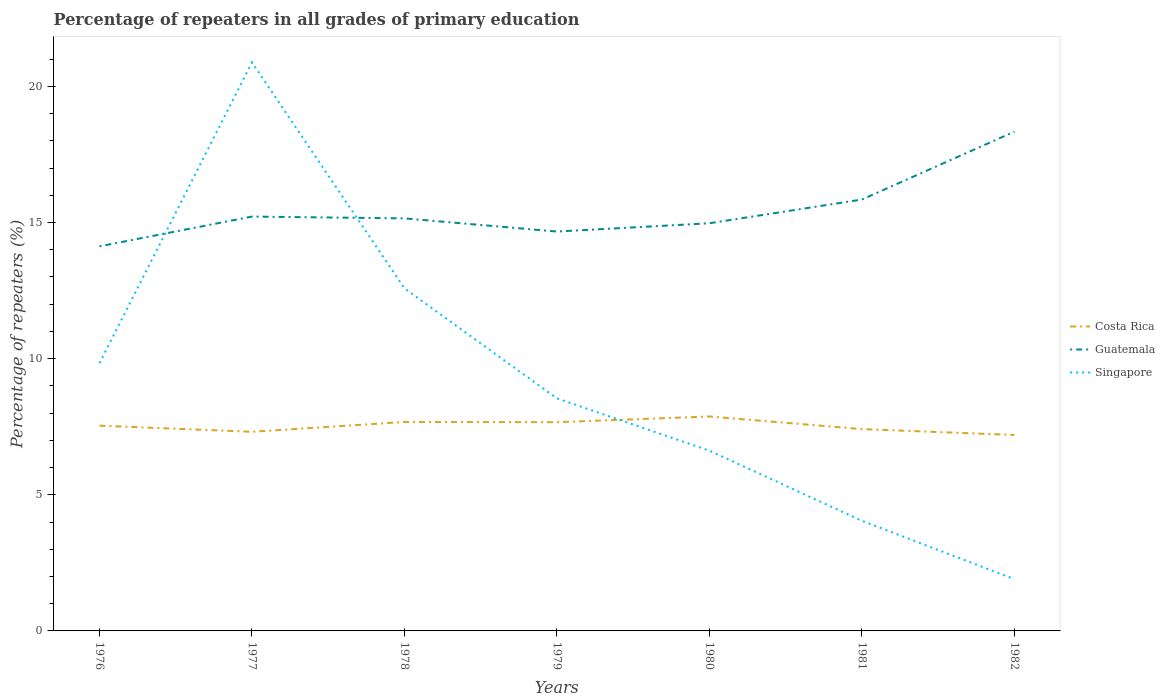Across all years, what is the maximum percentage of repeaters in Costa Rica?
Provide a succinct answer. 7.2. In which year was the percentage of repeaters in Singapore maximum?
Make the answer very short. 1982. What is the total percentage of repeaters in Costa Rica in the graph?
Make the answer very short. 0.01. What is the difference between the highest and the second highest percentage of repeaters in Costa Rica?
Make the answer very short. 0.68. Is the percentage of repeaters in Costa Rica strictly greater than the percentage of repeaters in Singapore over the years?
Your response must be concise. No. What is the difference between two consecutive major ticks on the Y-axis?
Offer a terse response. 5. Where does the legend appear in the graph?
Give a very brief answer. Center right. What is the title of the graph?
Make the answer very short. Percentage of repeaters in all grades of primary education. Does "Oman" appear as one of the legend labels in the graph?
Give a very brief answer. No. What is the label or title of the X-axis?
Your answer should be very brief. Years. What is the label or title of the Y-axis?
Provide a short and direct response. Percentage of repeaters (%). What is the Percentage of repeaters (%) of Costa Rica in 1976?
Give a very brief answer. 7.54. What is the Percentage of repeaters (%) in Guatemala in 1976?
Your response must be concise. 14.12. What is the Percentage of repeaters (%) in Singapore in 1976?
Provide a short and direct response. 9.83. What is the Percentage of repeaters (%) in Costa Rica in 1977?
Ensure brevity in your answer.  7.31. What is the Percentage of repeaters (%) in Guatemala in 1977?
Provide a succinct answer. 15.22. What is the Percentage of repeaters (%) of Singapore in 1977?
Ensure brevity in your answer.  20.88. What is the Percentage of repeaters (%) in Costa Rica in 1978?
Give a very brief answer. 7.67. What is the Percentage of repeaters (%) of Guatemala in 1978?
Your response must be concise. 15.15. What is the Percentage of repeaters (%) of Singapore in 1978?
Offer a terse response. 12.58. What is the Percentage of repeaters (%) of Costa Rica in 1979?
Make the answer very short. 7.67. What is the Percentage of repeaters (%) of Guatemala in 1979?
Keep it short and to the point. 14.67. What is the Percentage of repeaters (%) in Singapore in 1979?
Your answer should be very brief. 8.54. What is the Percentage of repeaters (%) in Costa Rica in 1980?
Give a very brief answer. 7.88. What is the Percentage of repeaters (%) in Guatemala in 1980?
Provide a succinct answer. 14.97. What is the Percentage of repeaters (%) of Singapore in 1980?
Provide a short and direct response. 6.62. What is the Percentage of repeaters (%) of Costa Rica in 1981?
Your answer should be compact. 7.41. What is the Percentage of repeaters (%) of Guatemala in 1981?
Offer a very short reply. 15.84. What is the Percentage of repeaters (%) of Singapore in 1981?
Give a very brief answer. 4.04. What is the Percentage of repeaters (%) in Costa Rica in 1982?
Give a very brief answer. 7.2. What is the Percentage of repeaters (%) of Guatemala in 1982?
Provide a short and direct response. 18.34. What is the Percentage of repeaters (%) in Singapore in 1982?
Provide a short and direct response. 1.9. Across all years, what is the maximum Percentage of repeaters (%) of Costa Rica?
Your response must be concise. 7.88. Across all years, what is the maximum Percentage of repeaters (%) of Guatemala?
Make the answer very short. 18.34. Across all years, what is the maximum Percentage of repeaters (%) of Singapore?
Keep it short and to the point. 20.88. Across all years, what is the minimum Percentage of repeaters (%) of Costa Rica?
Give a very brief answer. 7.2. Across all years, what is the minimum Percentage of repeaters (%) of Guatemala?
Your answer should be compact. 14.12. Across all years, what is the minimum Percentage of repeaters (%) of Singapore?
Your answer should be compact. 1.9. What is the total Percentage of repeaters (%) of Costa Rica in the graph?
Provide a succinct answer. 52.67. What is the total Percentage of repeaters (%) in Guatemala in the graph?
Make the answer very short. 108.31. What is the total Percentage of repeaters (%) in Singapore in the graph?
Offer a terse response. 64.4. What is the difference between the Percentage of repeaters (%) in Costa Rica in 1976 and that in 1977?
Your response must be concise. 0.23. What is the difference between the Percentage of repeaters (%) of Guatemala in 1976 and that in 1977?
Your answer should be very brief. -1.09. What is the difference between the Percentage of repeaters (%) of Singapore in 1976 and that in 1977?
Provide a succinct answer. -11.04. What is the difference between the Percentage of repeaters (%) of Costa Rica in 1976 and that in 1978?
Ensure brevity in your answer.  -0.14. What is the difference between the Percentage of repeaters (%) in Guatemala in 1976 and that in 1978?
Offer a very short reply. -1.03. What is the difference between the Percentage of repeaters (%) in Singapore in 1976 and that in 1978?
Ensure brevity in your answer.  -2.75. What is the difference between the Percentage of repeaters (%) in Costa Rica in 1976 and that in 1979?
Your response must be concise. -0.13. What is the difference between the Percentage of repeaters (%) of Guatemala in 1976 and that in 1979?
Provide a succinct answer. -0.54. What is the difference between the Percentage of repeaters (%) of Singapore in 1976 and that in 1979?
Your answer should be compact. 1.29. What is the difference between the Percentage of repeaters (%) of Costa Rica in 1976 and that in 1980?
Keep it short and to the point. -0.34. What is the difference between the Percentage of repeaters (%) in Guatemala in 1976 and that in 1980?
Ensure brevity in your answer.  -0.85. What is the difference between the Percentage of repeaters (%) of Singapore in 1976 and that in 1980?
Provide a succinct answer. 3.21. What is the difference between the Percentage of repeaters (%) in Costa Rica in 1976 and that in 1981?
Provide a short and direct response. 0.13. What is the difference between the Percentage of repeaters (%) of Guatemala in 1976 and that in 1981?
Your response must be concise. -1.72. What is the difference between the Percentage of repeaters (%) in Singapore in 1976 and that in 1981?
Your answer should be very brief. 5.79. What is the difference between the Percentage of repeaters (%) in Costa Rica in 1976 and that in 1982?
Provide a short and direct response. 0.34. What is the difference between the Percentage of repeaters (%) in Guatemala in 1976 and that in 1982?
Your response must be concise. -4.21. What is the difference between the Percentage of repeaters (%) in Singapore in 1976 and that in 1982?
Your response must be concise. 7.93. What is the difference between the Percentage of repeaters (%) of Costa Rica in 1977 and that in 1978?
Give a very brief answer. -0.36. What is the difference between the Percentage of repeaters (%) of Guatemala in 1977 and that in 1978?
Your answer should be compact. 0.07. What is the difference between the Percentage of repeaters (%) in Singapore in 1977 and that in 1978?
Provide a succinct answer. 8.3. What is the difference between the Percentage of repeaters (%) of Costa Rica in 1977 and that in 1979?
Your answer should be compact. -0.35. What is the difference between the Percentage of repeaters (%) in Guatemala in 1977 and that in 1979?
Provide a short and direct response. 0.55. What is the difference between the Percentage of repeaters (%) of Singapore in 1977 and that in 1979?
Provide a succinct answer. 12.34. What is the difference between the Percentage of repeaters (%) in Costa Rica in 1977 and that in 1980?
Offer a very short reply. -0.56. What is the difference between the Percentage of repeaters (%) of Guatemala in 1977 and that in 1980?
Your response must be concise. 0.25. What is the difference between the Percentage of repeaters (%) in Singapore in 1977 and that in 1980?
Your answer should be very brief. 14.26. What is the difference between the Percentage of repeaters (%) of Costa Rica in 1977 and that in 1981?
Provide a succinct answer. -0.1. What is the difference between the Percentage of repeaters (%) in Guatemala in 1977 and that in 1981?
Provide a succinct answer. -0.63. What is the difference between the Percentage of repeaters (%) of Singapore in 1977 and that in 1981?
Give a very brief answer. 16.83. What is the difference between the Percentage of repeaters (%) in Costa Rica in 1977 and that in 1982?
Offer a terse response. 0.12. What is the difference between the Percentage of repeaters (%) in Guatemala in 1977 and that in 1982?
Provide a succinct answer. -3.12. What is the difference between the Percentage of repeaters (%) in Singapore in 1977 and that in 1982?
Ensure brevity in your answer.  18.98. What is the difference between the Percentage of repeaters (%) in Costa Rica in 1978 and that in 1979?
Your response must be concise. 0.01. What is the difference between the Percentage of repeaters (%) in Guatemala in 1978 and that in 1979?
Provide a short and direct response. 0.48. What is the difference between the Percentage of repeaters (%) of Singapore in 1978 and that in 1979?
Provide a succinct answer. 4.04. What is the difference between the Percentage of repeaters (%) of Costa Rica in 1978 and that in 1980?
Your response must be concise. -0.2. What is the difference between the Percentage of repeaters (%) in Guatemala in 1978 and that in 1980?
Provide a succinct answer. 0.18. What is the difference between the Percentage of repeaters (%) in Singapore in 1978 and that in 1980?
Your answer should be compact. 5.96. What is the difference between the Percentage of repeaters (%) of Costa Rica in 1978 and that in 1981?
Provide a short and direct response. 0.26. What is the difference between the Percentage of repeaters (%) of Guatemala in 1978 and that in 1981?
Offer a terse response. -0.69. What is the difference between the Percentage of repeaters (%) in Singapore in 1978 and that in 1981?
Your answer should be very brief. 8.54. What is the difference between the Percentage of repeaters (%) of Costa Rica in 1978 and that in 1982?
Provide a short and direct response. 0.48. What is the difference between the Percentage of repeaters (%) of Guatemala in 1978 and that in 1982?
Provide a succinct answer. -3.19. What is the difference between the Percentage of repeaters (%) in Singapore in 1978 and that in 1982?
Your response must be concise. 10.68. What is the difference between the Percentage of repeaters (%) of Costa Rica in 1979 and that in 1980?
Offer a terse response. -0.21. What is the difference between the Percentage of repeaters (%) of Guatemala in 1979 and that in 1980?
Provide a succinct answer. -0.3. What is the difference between the Percentage of repeaters (%) of Singapore in 1979 and that in 1980?
Your answer should be compact. 1.92. What is the difference between the Percentage of repeaters (%) of Costa Rica in 1979 and that in 1981?
Your response must be concise. 0.25. What is the difference between the Percentage of repeaters (%) in Guatemala in 1979 and that in 1981?
Give a very brief answer. -1.18. What is the difference between the Percentage of repeaters (%) of Singapore in 1979 and that in 1981?
Your answer should be compact. 4.5. What is the difference between the Percentage of repeaters (%) of Costa Rica in 1979 and that in 1982?
Provide a succinct answer. 0.47. What is the difference between the Percentage of repeaters (%) of Guatemala in 1979 and that in 1982?
Make the answer very short. -3.67. What is the difference between the Percentage of repeaters (%) of Singapore in 1979 and that in 1982?
Give a very brief answer. 6.64. What is the difference between the Percentage of repeaters (%) of Costa Rica in 1980 and that in 1981?
Make the answer very short. 0.46. What is the difference between the Percentage of repeaters (%) in Guatemala in 1980 and that in 1981?
Keep it short and to the point. -0.87. What is the difference between the Percentage of repeaters (%) in Singapore in 1980 and that in 1981?
Your answer should be very brief. 2.57. What is the difference between the Percentage of repeaters (%) in Costa Rica in 1980 and that in 1982?
Ensure brevity in your answer.  0.68. What is the difference between the Percentage of repeaters (%) in Guatemala in 1980 and that in 1982?
Offer a very short reply. -3.36. What is the difference between the Percentage of repeaters (%) of Singapore in 1980 and that in 1982?
Keep it short and to the point. 4.72. What is the difference between the Percentage of repeaters (%) in Costa Rica in 1981 and that in 1982?
Ensure brevity in your answer.  0.22. What is the difference between the Percentage of repeaters (%) of Guatemala in 1981 and that in 1982?
Keep it short and to the point. -2.49. What is the difference between the Percentage of repeaters (%) of Singapore in 1981 and that in 1982?
Give a very brief answer. 2.14. What is the difference between the Percentage of repeaters (%) of Costa Rica in 1976 and the Percentage of repeaters (%) of Guatemala in 1977?
Provide a succinct answer. -7.68. What is the difference between the Percentage of repeaters (%) in Costa Rica in 1976 and the Percentage of repeaters (%) in Singapore in 1977?
Offer a very short reply. -13.34. What is the difference between the Percentage of repeaters (%) in Guatemala in 1976 and the Percentage of repeaters (%) in Singapore in 1977?
Ensure brevity in your answer.  -6.75. What is the difference between the Percentage of repeaters (%) in Costa Rica in 1976 and the Percentage of repeaters (%) in Guatemala in 1978?
Offer a very short reply. -7.61. What is the difference between the Percentage of repeaters (%) of Costa Rica in 1976 and the Percentage of repeaters (%) of Singapore in 1978?
Your response must be concise. -5.04. What is the difference between the Percentage of repeaters (%) of Guatemala in 1976 and the Percentage of repeaters (%) of Singapore in 1978?
Your answer should be very brief. 1.54. What is the difference between the Percentage of repeaters (%) of Costa Rica in 1976 and the Percentage of repeaters (%) of Guatemala in 1979?
Provide a short and direct response. -7.13. What is the difference between the Percentage of repeaters (%) in Costa Rica in 1976 and the Percentage of repeaters (%) in Singapore in 1979?
Give a very brief answer. -1. What is the difference between the Percentage of repeaters (%) in Guatemala in 1976 and the Percentage of repeaters (%) in Singapore in 1979?
Provide a succinct answer. 5.58. What is the difference between the Percentage of repeaters (%) of Costa Rica in 1976 and the Percentage of repeaters (%) of Guatemala in 1980?
Your answer should be compact. -7.43. What is the difference between the Percentage of repeaters (%) in Costa Rica in 1976 and the Percentage of repeaters (%) in Singapore in 1980?
Your response must be concise. 0.92. What is the difference between the Percentage of repeaters (%) in Guatemala in 1976 and the Percentage of repeaters (%) in Singapore in 1980?
Your answer should be compact. 7.5. What is the difference between the Percentage of repeaters (%) in Costa Rica in 1976 and the Percentage of repeaters (%) in Guatemala in 1981?
Keep it short and to the point. -8.3. What is the difference between the Percentage of repeaters (%) in Costa Rica in 1976 and the Percentage of repeaters (%) in Singapore in 1981?
Provide a succinct answer. 3.49. What is the difference between the Percentage of repeaters (%) of Guatemala in 1976 and the Percentage of repeaters (%) of Singapore in 1981?
Keep it short and to the point. 10.08. What is the difference between the Percentage of repeaters (%) of Costa Rica in 1976 and the Percentage of repeaters (%) of Guatemala in 1982?
Provide a short and direct response. -10.8. What is the difference between the Percentage of repeaters (%) of Costa Rica in 1976 and the Percentage of repeaters (%) of Singapore in 1982?
Make the answer very short. 5.64. What is the difference between the Percentage of repeaters (%) of Guatemala in 1976 and the Percentage of repeaters (%) of Singapore in 1982?
Make the answer very short. 12.22. What is the difference between the Percentage of repeaters (%) in Costa Rica in 1977 and the Percentage of repeaters (%) in Guatemala in 1978?
Your answer should be very brief. -7.84. What is the difference between the Percentage of repeaters (%) of Costa Rica in 1977 and the Percentage of repeaters (%) of Singapore in 1978?
Your answer should be very brief. -5.27. What is the difference between the Percentage of repeaters (%) of Guatemala in 1977 and the Percentage of repeaters (%) of Singapore in 1978?
Ensure brevity in your answer.  2.64. What is the difference between the Percentage of repeaters (%) of Costa Rica in 1977 and the Percentage of repeaters (%) of Guatemala in 1979?
Your answer should be compact. -7.35. What is the difference between the Percentage of repeaters (%) of Costa Rica in 1977 and the Percentage of repeaters (%) of Singapore in 1979?
Your answer should be compact. -1.23. What is the difference between the Percentage of repeaters (%) in Guatemala in 1977 and the Percentage of repeaters (%) in Singapore in 1979?
Keep it short and to the point. 6.68. What is the difference between the Percentage of repeaters (%) of Costa Rica in 1977 and the Percentage of repeaters (%) of Guatemala in 1980?
Ensure brevity in your answer.  -7.66. What is the difference between the Percentage of repeaters (%) of Costa Rica in 1977 and the Percentage of repeaters (%) of Singapore in 1980?
Ensure brevity in your answer.  0.69. What is the difference between the Percentage of repeaters (%) in Guatemala in 1977 and the Percentage of repeaters (%) in Singapore in 1980?
Provide a succinct answer. 8.6. What is the difference between the Percentage of repeaters (%) of Costa Rica in 1977 and the Percentage of repeaters (%) of Guatemala in 1981?
Make the answer very short. -8.53. What is the difference between the Percentage of repeaters (%) in Costa Rica in 1977 and the Percentage of repeaters (%) in Singapore in 1981?
Provide a succinct answer. 3.27. What is the difference between the Percentage of repeaters (%) in Guatemala in 1977 and the Percentage of repeaters (%) in Singapore in 1981?
Ensure brevity in your answer.  11.17. What is the difference between the Percentage of repeaters (%) of Costa Rica in 1977 and the Percentage of repeaters (%) of Guatemala in 1982?
Offer a terse response. -11.02. What is the difference between the Percentage of repeaters (%) of Costa Rica in 1977 and the Percentage of repeaters (%) of Singapore in 1982?
Your answer should be compact. 5.41. What is the difference between the Percentage of repeaters (%) in Guatemala in 1977 and the Percentage of repeaters (%) in Singapore in 1982?
Make the answer very short. 13.32. What is the difference between the Percentage of repeaters (%) in Costa Rica in 1978 and the Percentage of repeaters (%) in Guatemala in 1979?
Your answer should be very brief. -6.99. What is the difference between the Percentage of repeaters (%) in Costa Rica in 1978 and the Percentage of repeaters (%) in Singapore in 1979?
Your response must be concise. -0.87. What is the difference between the Percentage of repeaters (%) of Guatemala in 1978 and the Percentage of repeaters (%) of Singapore in 1979?
Ensure brevity in your answer.  6.61. What is the difference between the Percentage of repeaters (%) of Costa Rica in 1978 and the Percentage of repeaters (%) of Guatemala in 1980?
Your answer should be very brief. -7.3. What is the difference between the Percentage of repeaters (%) in Costa Rica in 1978 and the Percentage of repeaters (%) in Singapore in 1980?
Your answer should be compact. 1.06. What is the difference between the Percentage of repeaters (%) of Guatemala in 1978 and the Percentage of repeaters (%) of Singapore in 1980?
Your answer should be compact. 8.53. What is the difference between the Percentage of repeaters (%) in Costa Rica in 1978 and the Percentage of repeaters (%) in Guatemala in 1981?
Your answer should be very brief. -8.17. What is the difference between the Percentage of repeaters (%) in Costa Rica in 1978 and the Percentage of repeaters (%) in Singapore in 1981?
Provide a succinct answer. 3.63. What is the difference between the Percentage of repeaters (%) in Guatemala in 1978 and the Percentage of repeaters (%) in Singapore in 1981?
Your answer should be compact. 11.11. What is the difference between the Percentage of repeaters (%) of Costa Rica in 1978 and the Percentage of repeaters (%) of Guatemala in 1982?
Make the answer very short. -10.66. What is the difference between the Percentage of repeaters (%) of Costa Rica in 1978 and the Percentage of repeaters (%) of Singapore in 1982?
Keep it short and to the point. 5.77. What is the difference between the Percentage of repeaters (%) of Guatemala in 1978 and the Percentage of repeaters (%) of Singapore in 1982?
Offer a very short reply. 13.25. What is the difference between the Percentage of repeaters (%) in Costa Rica in 1979 and the Percentage of repeaters (%) in Guatemala in 1980?
Provide a short and direct response. -7.31. What is the difference between the Percentage of repeaters (%) in Costa Rica in 1979 and the Percentage of repeaters (%) in Singapore in 1980?
Make the answer very short. 1.05. What is the difference between the Percentage of repeaters (%) of Guatemala in 1979 and the Percentage of repeaters (%) of Singapore in 1980?
Your answer should be very brief. 8.05. What is the difference between the Percentage of repeaters (%) of Costa Rica in 1979 and the Percentage of repeaters (%) of Guatemala in 1981?
Offer a very short reply. -8.18. What is the difference between the Percentage of repeaters (%) in Costa Rica in 1979 and the Percentage of repeaters (%) in Singapore in 1981?
Make the answer very short. 3.62. What is the difference between the Percentage of repeaters (%) of Guatemala in 1979 and the Percentage of repeaters (%) of Singapore in 1981?
Make the answer very short. 10.62. What is the difference between the Percentage of repeaters (%) of Costa Rica in 1979 and the Percentage of repeaters (%) of Guatemala in 1982?
Provide a short and direct response. -10.67. What is the difference between the Percentage of repeaters (%) in Costa Rica in 1979 and the Percentage of repeaters (%) in Singapore in 1982?
Ensure brevity in your answer.  5.77. What is the difference between the Percentage of repeaters (%) of Guatemala in 1979 and the Percentage of repeaters (%) of Singapore in 1982?
Keep it short and to the point. 12.77. What is the difference between the Percentage of repeaters (%) of Costa Rica in 1980 and the Percentage of repeaters (%) of Guatemala in 1981?
Your answer should be very brief. -7.97. What is the difference between the Percentage of repeaters (%) in Costa Rica in 1980 and the Percentage of repeaters (%) in Singapore in 1981?
Your answer should be very brief. 3.83. What is the difference between the Percentage of repeaters (%) in Guatemala in 1980 and the Percentage of repeaters (%) in Singapore in 1981?
Offer a terse response. 10.93. What is the difference between the Percentage of repeaters (%) in Costa Rica in 1980 and the Percentage of repeaters (%) in Guatemala in 1982?
Your answer should be very brief. -10.46. What is the difference between the Percentage of repeaters (%) in Costa Rica in 1980 and the Percentage of repeaters (%) in Singapore in 1982?
Make the answer very short. 5.97. What is the difference between the Percentage of repeaters (%) of Guatemala in 1980 and the Percentage of repeaters (%) of Singapore in 1982?
Ensure brevity in your answer.  13.07. What is the difference between the Percentage of repeaters (%) of Costa Rica in 1981 and the Percentage of repeaters (%) of Guatemala in 1982?
Your answer should be very brief. -10.92. What is the difference between the Percentage of repeaters (%) of Costa Rica in 1981 and the Percentage of repeaters (%) of Singapore in 1982?
Give a very brief answer. 5.51. What is the difference between the Percentage of repeaters (%) of Guatemala in 1981 and the Percentage of repeaters (%) of Singapore in 1982?
Offer a very short reply. 13.94. What is the average Percentage of repeaters (%) in Costa Rica per year?
Provide a short and direct response. 7.52. What is the average Percentage of repeaters (%) in Guatemala per year?
Offer a very short reply. 15.47. What is the average Percentage of repeaters (%) in Singapore per year?
Provide a short and direct response. 9.2. In the year 1976, what is the difference between the Percentage of repeaters (%) of Costa Rica and Percentage of repeaters (%) of Guatemala?
Provide a succinct answer. -6.59. In the year 1976, what is the difference between the Percentage of repeaters (%) of Costa Rica and Percentage of repeaters (%) of Singapore?
Offer a terse response. -2.3. In the year 1976, what is the difference between the Percentage of repeaters (%) of Guatemala and Percentage of repeaters (%) of Singapore?
Offer a very short reply. 4.29. In the year 1977, what is the difference between the Percentage of repeaters (%) in Costa Rica and Percentage of repeaters (%) in Guatemala?
Ensure brevity in your answer.  -7.9. In the year 1977, what is the difference between the Percentage of repeaters (%) in Costa Rica and Percentage of repeaters (%) in Singapore?
Make the answer very short. -13.56. In the year 1977, what is the difference between the Percentage of repeaters (%) of Guatemala and Percentage of repeaters (%) of Singapore?
Provide a short and direct response. -5.66. In the year 1978, what is the difference between the Percentage of repeaters (%) of Costa Rica and Percentage of repeaters (%) of Guatemala?
Make the answer very short. -7.48. In the year 1978, what is the difference between the Percentage of repeaters (%) of Costa Rica and Percentage of repeaters (%) of Singapore?
Offer a terse response. -4.91. In the year 1978, what is the difference between the Percentage of repeaters (%) of Guatemala and Percentage of repeaters (%) of Singapore?
Provide a short and direct response. 2.57. In the year 1979, what is the difference between the Percentage of repeaters (%) in Costa Rica and Percentage of repeaters (%) in Guatemala?
Provide a short and direct response. -7. In the year 1979, what is the difference between the Percentage of repeaters (%) in Costa Rica and Percentage of repeaters (%) in Singapore?
Offer a terse response. -0.87. In the year 1979, what is the difference between the Percentage of repeaters (%) of Guatemala and Percentage of repeaters (%) of Singapore?
Make the answer very short. 6.13. In the year 1980, what is the difference between the Percentage of repeaters (%) of Costa Rica and Percentage of repeaters (%) of Guatemala?
Your response must be concise. -7.1. In the year 1980, what is the difference between the Percentage of repeaters (%) of Costa Rica and Percentage of repeaters (%) of Singapore?
Make the answer very short. 1.26. In the year 1980, what is the difference between the Percentage of repeaters (%) of Guatemala and Percentage of repeaters (%) of Singapore?
Offer a very short reply. 8.35. In the year 1981, what is the difference between the Percentage of repeaters (%) in Costa Rica and Percentage of repeaters (%) in Guatemala?
Your response must be concise. -8.43. In the year 1981, what is the difference between the Percentage of repeaters (%) of Costa Rica and Percentage of repeaters (%) of Singapore?
Your response must be concise. 3.37. In the year 1981, what is the difference between the Percentage of repeaters (%) of Guatemala and Percentage of repeaters (%) of Singapore?
Your answer should be compact. 11.8. In the year 1982, what is the difference between the Percentage of repeaters (%) of Costa Rica and Percentage of repeaters (%) of Guatemala?
Your response must be concise. -11.14. In the year 1982, what is the difference between the Percentage of repeaters (%) of Costa Rica and Percentage of repeaters (%) of Singapore?
Provide a succinct answer. 5.29. In the year 1982, what is the difference between the Percentage of repeaters (%) in Guatemala and Percentage of repeaters (%) in Singapore?
Provide a short and direct response. 16.44. What is the ratio of the Percentage of repeaters (%) of Costa Rica in 1976 to that in 1977?
Your answer should be very brief. 1.03. What is the ratio of the Percentage of repeaters (%) of Guatemala in 1976 to that in 1977?
Offer a terse response. 0.93. What is the ratio of the Percentage of repeaters (%) in Singapore in 1976 to that in 1977?
Provide a short and direct response. 0.47. What is the ratio of the Percentage of repeaters (%) in Costa Rica in 1976 to that in 1978?
Your answer should be compact. 0.98. What is the ratio of the Percentage of repeaters (%) in Guatemala in 1976 to that in 1978?
Your response must be concise. 0.93. What is the ratio of the Percentage of repeaters (%) of Singapore in 1976 to that in 1978?
Offer a terse response. 0.78. What is the ratio of the Percentage of repeaters (%) of Costa Rica in 1976 to that in 1979?
Provide a succinct answer. 0.98. What is the ratio of the Percentage of repeaters (%) of Singapore in 1976 to that in 1979?
Offer a terse response. 1.15. What is the ratio of the Percentage of repeaters (%) in Costa Rica in 1976 to that in 1980?
Offer a terse response. 0.96. What is the ratio of the Percentage of repeaters (%) in Guatemala in 1976 to that in 1980?
Keep it short and to the point. 0.94. What is the ratio of the Percentage of repeaters (%) of Singapore in 1976 to that in 1980?
Your response must be concise. 1.49. What is the ratio of the Percentage of repeaters (%) in Costa Rica in 1976 to that in 1981?
Offer a terse response. 1.02. What is the ratio of the Percentage of repeaters (%) of Guatemala in 1976 to that in 1981?
Provide a succinct answer. 0.89. What is the ratio of the Percentage of repeaters (%) in Singapore in 1976 to that in 1981?
Give a very brief answer. 2.43. What is the ratio of the Percentage of repeaters (%) of Costa Rica in 1976 to that in 1982?
Offer a terse response. 1.05. What is the ratio of the Percentage of repeaters (%) of Guatemala in 1976 to that in 1982?
Provide a short and direct response. 0.77. What is the ratio of the Percentage of repeaters (%) in Singapore in 1976 to that in 1982?
Your answer should be very brief. 5.17. What is the ratio of the Percentage of repeaters (%) in Costa Rica in 1977 to that in 1978?
Keep it short and to the point. 0.95. What is the ratio of the Percentage of repeaters (%) of Singapore in 1977 to that in 1978?
Your response must be concise. 1.66. What is the ratio of the Percentage of repeaters (%) in Costa Rica in 1977 to that in 1979?
Your answer should be compact. 0.95. What is the ratio of the Percentage of repeaters (%) in Guatemala in 1977 to that in 1979?
Keep it short and to the point. 1.04. What is the ratio of the Percentage of repeaters (%) in Singapore in 1977 to that in 1979?
Offer a very short reply. 2.44. What is the ratio of the Percentage of repeaters (%) in Costa Rica in 1977 to that in 1980?
Your response must be concise. 0.93. What is the ratio of the Percentage of repeaters (%) of Guatemala in 1977 to that in 1980?
Your answer should be compact. 1.02. What is the ratio of the Percentage of repeaters (%) of Singapore in 1977 to that in 1980?
Offer a terse response. 3.15. What is the ratio of the Percentage of repeaters (%) in Costa Rica in 1977 to that in 1981?
Your response must be concise. 0.99. What is the ratio of the Percentage of repeaters (%) in Guatemala in 1977 to that in 1981?
Provide a succinct answer. 0.96. What is the ratio of the Percentage of repeaters (%) in Singapore in 1977 to that in 1981?
Make the answer very short. 5.16. What is the ratio of the Percentage of repeaters (%) in Costa Rica in 1977 to that in 1982?
Your response must be concise. 1.02. What is the ratio of the Percentage of repeaters (%) in Guatemala in 1977 to that in 1982?
Your answer should be very brief. 0.83. What is the ratio of the Percentage of repeaters (%) of Singapore in 1977 to that in 1982?
Your response must be concise. 10.98. What is the ratio of the Percentage of repeaters (%) of Guatemala in 1978 to that in 1979?
Offer a terse response. 1.03. What is the ratio of the Percentage of repeaters (%) in Singapore in 1978 to that in 1979?
Your answer should be very brief. 1.47. What is the ratio of the Percentage of repeaters (%) of Costa Rica in 1978 to that in 1980?
Your answer should be very brief. 0.97. What is the ratio of the Percentage of repeaters (%) of Singapore in 1978 to that in 1980?
Your answer should be compact. 1.9. What is the ratio of the Percentage of repeaters (%) in Costa Rica in 1978 to that in 1981?
Ensure brevity in your answer.  1.04. What is the ratio of the Percentage of repeaters (%) in Guatemala in 1978 to that in 1981?
Your answer should be very brief. 0.96. What is the ratio of the Percentage of repeaters (%) in Singapore in 1978 to that in 1981?
Your response must be concise. 3.11. What is the ratio of the Percentage of repeaters (%) of Costa Rica in 1978 to that in 1982?
Your response must be concise. 1.07. What is the ratio of the Percentage of repeaters (%) in Guatemala in 1978 to that in 1982?
Your answer should be compact. 0.83. What is the ratio of the Percentage of repeaters (%) of Singapore in 1978 to that in 1982?
Provide a short and direct response. 6.62. What is the ratio of the Percentage of repeaters (%) in Costa Rica in 1979 to that in 1980?
Provide a short and direct response. 0.97. What is the ratio of the Percentage of repeaters (%) in Guatemala in 1979 to that in 1980?
Offer a very short reply. 0.98. What is the ratio of the Percentage of repeaters (%) in Singapore in 1979 to that in 1980?
Provide a short and direct response. 1.29. What is the ratio of the Percentage of repeaters (%) in Costa Rica in 1979 to that in 1981?
Make the answer very short. 1.03. What is the ratio of the Percentage of repeaters (%) in Guatemala in 1979 to that in 1981?
Ensure brevity in your answer.  0.93. What is the ratio of the Percentage of repeaters (%) of Singapore in 1979 to that in 1981?
Keep it short and to the point. 2.11. What is the ratio of the Percentage of repeaters (%) in Costa Rica in 1979 to that in 1982?
Make the answer very short. 1.07. What is the ratio of the Percentage of repeaters (%) of Guatemala in 1979 to that in 1982?
Provide a succinct answer. 0.8. What is the ratio of the Percentage of repeaters (%) of Singapore in 1979 to that in 1982?
Your answer should be very brief. 4.49. What is the ratio of the Percentage of repeaters (%) in Costa Rica in 1980 to that in 1981?
Give a very brief answer. 1.06. What is the ratio of the Percentage of repeaters (%) in Guatemala in 1980 to that in 1981?
Give a very brief answer. 0.94. What is the ratio of the Percentage of repeaters (%) in Singapore in 1980 to that in 1981?
Offer a very short reply. 1.64. What is the ratio of the Percentage of repeaters (%) of Costa Rica in 1980 to that in 1982?
Make the answer very short. 1.09. What is the ratio of the Percentage of repeaters (%) in Guatemala in 1980 to that in 1982?
Offer a terse response. 0.82. What is the ratio of the Percentage of repeaters (%) in Singapore in 1980 to that in 1982?
Your answer should be compact. 3.48. What is the ratio of the Percentage of repeaters (%) in Costa Rica in 1981 to that in 1982?
Your answer should be very brief. 1.03. What is the ratio of the Percentage of repeaters (%) of Guatemala in 1981 to that in 1982?
Keep it short and to the point. 0.86. What is the ratio of the Percentage of repeaters (%) in Singapore in 1981 to that in 1982?
Offer a very short reply. 2.13. What is the difference between the highest and the second highest Percentage of repeaters (%) in Costa Rica?
Offer a very short reply. 0.2. What is the difference between the highest and the second highest Percentage of repeaters (%) of Guatemala?
Your answer should be very brief. 2.49. What is the difference between the highest and the second highest Percentage of repeaters (%) of Singapore?
Your answer should be compact. 8.3. What is the difference between the highest and the lowest Percentage of repeaters (%) in Costa Rica?
Offer a very short reply. 0.68. What is the difference between the highest and the lowest Percentage of repeaters (%) of Guatemala?
Your response must be concise. 4.21. What is the difference between the highest and the lowest Percentage of repeaters (%) of Singapore?
Provide a short and direct response. 18.98. 